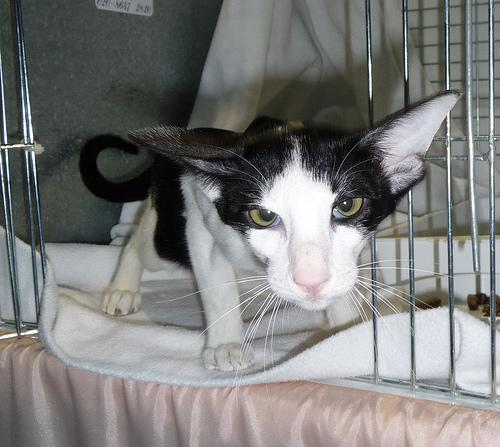Question: who is in the image?
Choices:
A. Bear.
B. Dog.
C. Bird.
D. Cat.
Answer with the letter. Answer: D Question: what is the color of cat?
Choices:
A. Tan.
B. Black and white.
C. Beige.
D. Grey.
Answer with the letter. Answer: B Question: when is the image taken?
Choices:
A. Cat is inside.
B. At lunch.
C. At dinner.
D. At breakfast.
Answer with the letter. Answer: A 